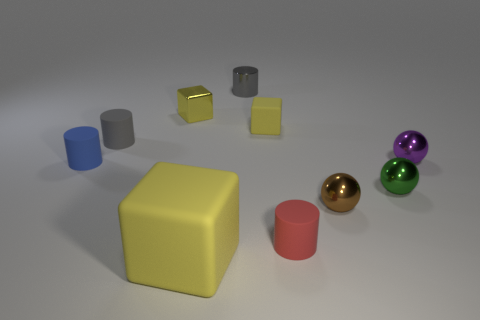Subtract all cyan spheres. How many gray cylinders are left? 2 Subtract all rubber blocks. How many blocks are left? 1 Subtract all red cylinders. How many cylinders are left? 3 Subtract 1 balls. How many balls are left? 2 Subtract all cylinders. How many objects are left? 6 Subtract all yellow cylinders. Subtract all yellow spheres. How many cylinders are left? 4 Subtract 1 purple balls. How many objects are left? 9 Subtract all cyan cubes. Subtract all small gray things. How many objects are left? 8 Add 1 tiny objects. How many tiny objects are left? 10 Add 7 big yellow blocks. How many big yellow blocks exist? 8 